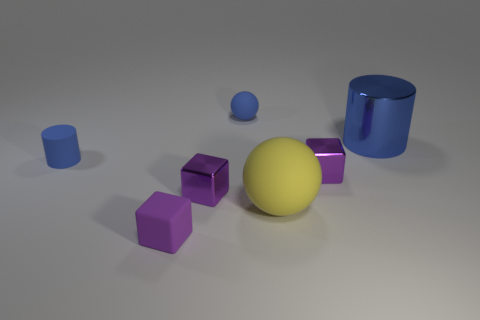Subtract all small metallic blocks. How many blocks are left? 1 Subtract all yellow spheres. How many spheres are left? 1 Subtract 3 blocks. How many blocks are left? 0 Add 1 small cyan rubber cylinders. How many objects exist? 8 Subtract all cylinders. How many objects are left? 5 Subtract all green blocks. How many yellow spheres are left? 1 Subtract all tiny blue balls. Subtract all tiny rubber cylinders. How many objects are left? 5 Add 5 small rubber balls. How many small rubber balls are left? 6 Add 5 yellow metal blocks. How many yellow metal blocks exist? 5 Subtract 0 brown blocks. How many objects are left? 7 